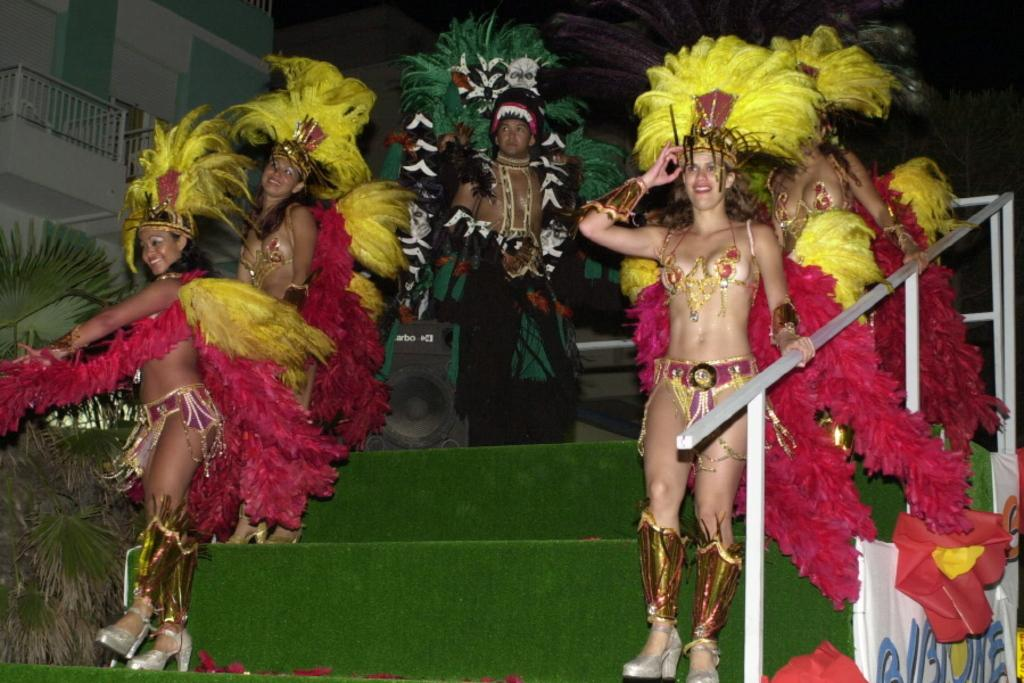What are the people in the image doing? The people are standing on the steps in the image. What are the people wearing? The people are wearing costumes in the image. What can be seen in the background of the image? There are buildings in the image, and the background is dark. Are there any signs or messages visible in the image? Yes, there are posters with text in the image. How does the toothpaste increase in the image? There is no toothpaste present in the image, so it cannot be determined how it might increase. 